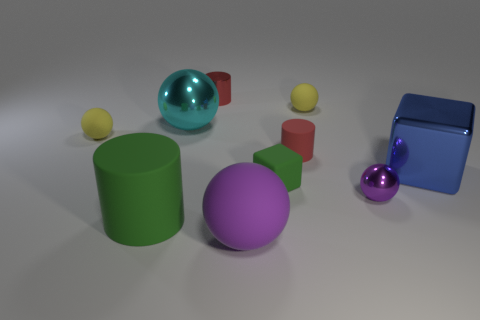Subtract all large balls. How many balls are left? 3 Subtract all yellow spheres. How many spheres are left? 3 Subtract all blue balls. How many red cylinders are left? 2 Subtract all blocks. How many objects are left? 8 Add 8 gray matte things. How many gray matte things exist? 8 Subtract 0 cyan blocks. How many objects are left? 10 Subtract 2 blocks. How many blocks are left? 0 Subtract all red cubes. Subtract all gray balls. How many cubes are left? 2 Subtract all large blue metal blocks. Subtract all balls. How many objects are left? 4 Add 7 green objects. How many green objects are left? 9 